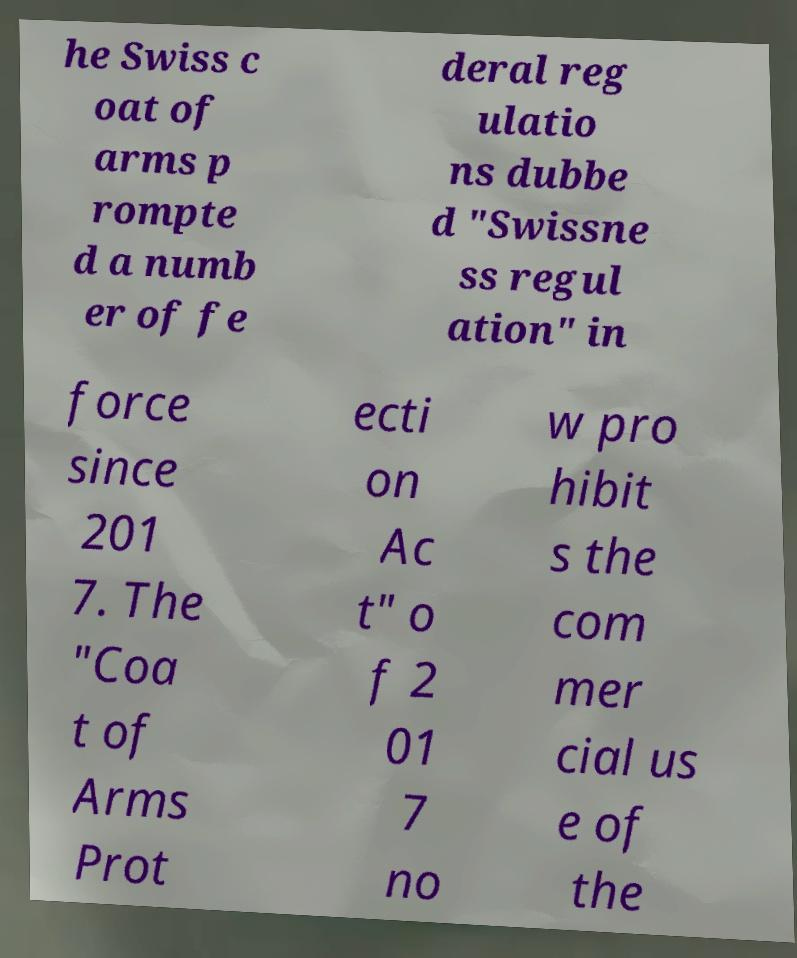Could you assist in decoding the text presented in this image and type it out clearly? he Swiss c oat of arms p rompte d a numb er of fe deral reg ulatio ns dubbe d "Swissne ss regul ation" in force since 201 7. The "Coa t of Arms Prot ecti on Ac t" o f 2 01 7 no w pro hibit s the com mer cial us e of the 